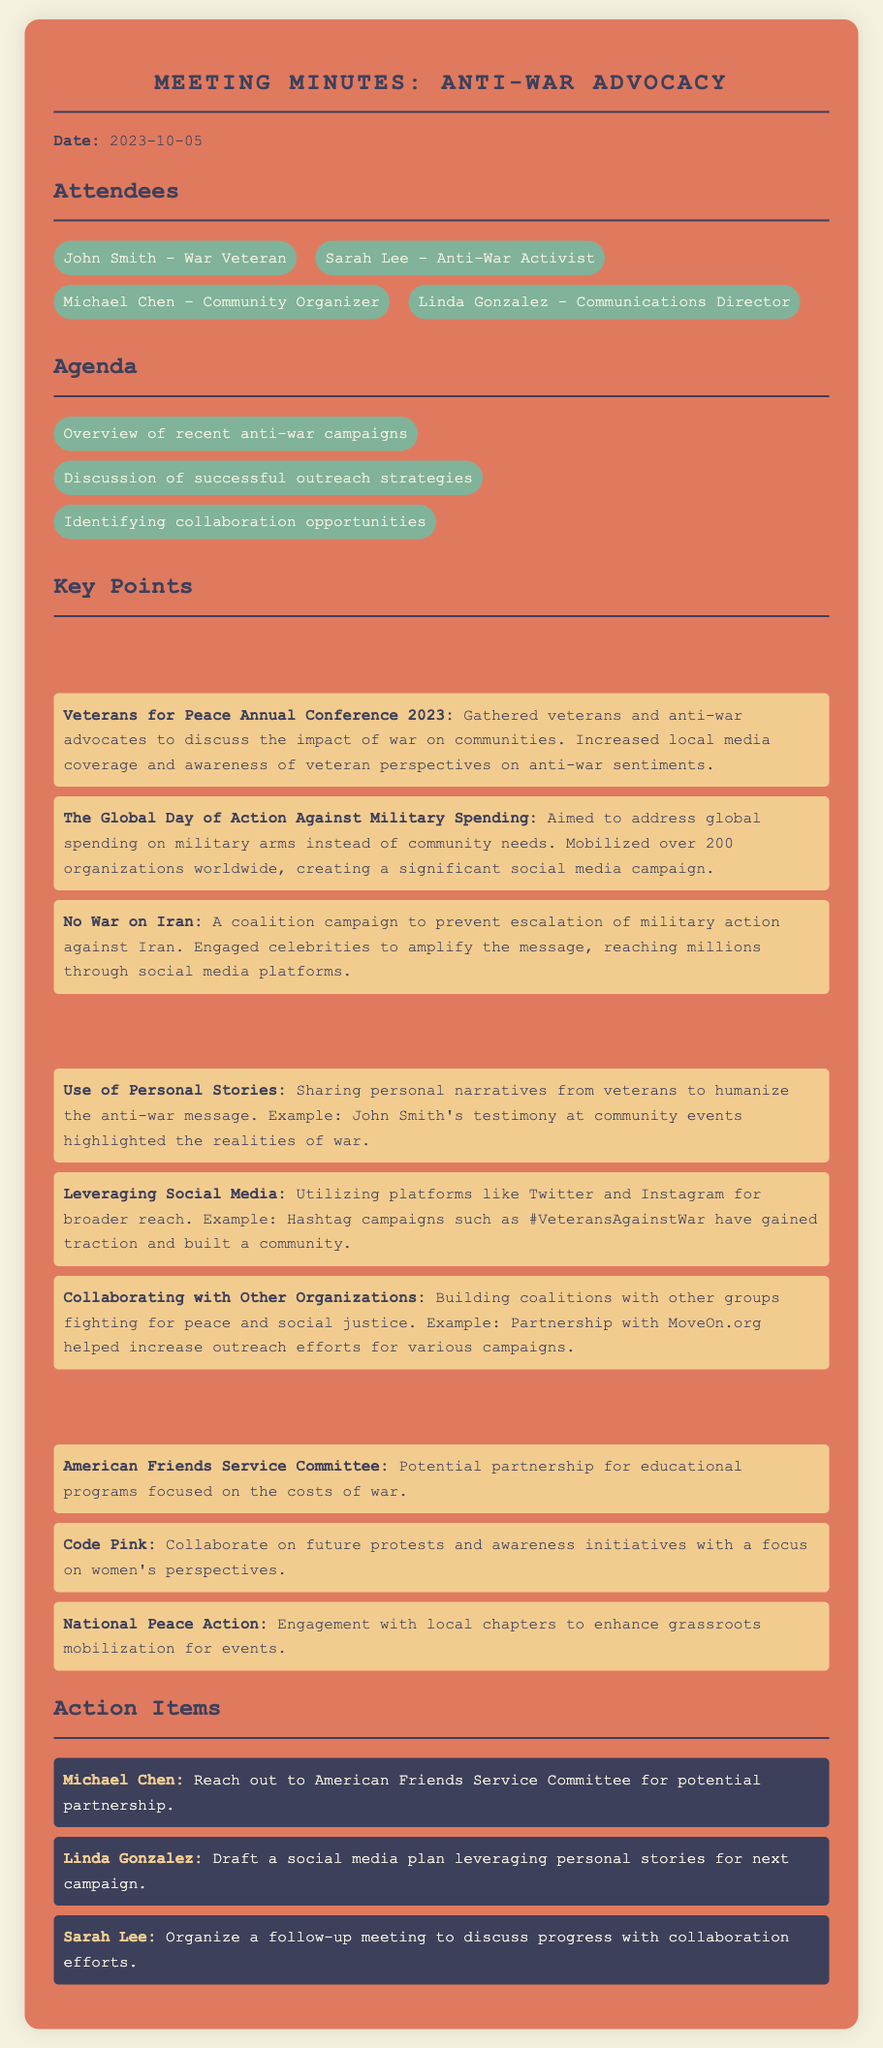What is the date of the meeting? The date of the meeting is explicitly mentioned in the document under the date section.
Answer: 2023-10-05 Who is the communications director? The attendees list provides the names and roles of each participant, including their titles.
Answer: Linda Gonzalez What was the theme of the Veterans for Peace Annual Conference 2023? The summary of the campaign provides insights into its objectives and outcomes.
Answer: Impact of war on communities How many organizations mobilized for the Global Day of Action Against Military Spending? The document specifies the number of organizations engaged in the campaign.
Answer: Over 200 What social media campaign gained traction with the hashtag #VeteransAgainstWar? The effective outreach strategies portion mentions this specific hashtag campaign.
Answer: Hashtag campaigns What potential partnership is mentioned with the American Friends Service Committee? The collaboration opportunities section indicates the topic of potential partnership.
Answer: Educational programs focused on the costs of war Who is responsible for reaching out to the American Friends Service Committee? The action items section lists the participants and their assigned tasks.
Answer: Michael Chen What major opportunity is suggested for collaboration with Code Pink? The collaboration opportunities outline specific initiatives that can be pursued.
Answer: Future protests and awareness initiatives with a focus on women's perspectives 